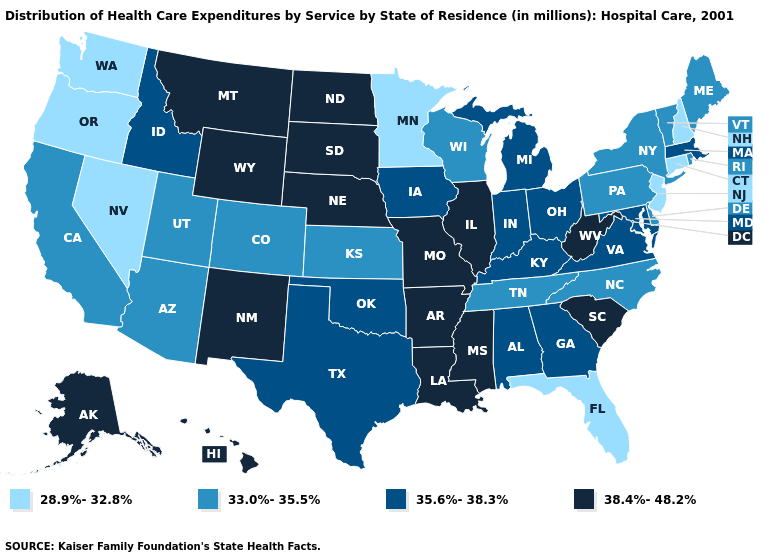What is the value of Alabama?
Quick response, please. 35.6%-38.3%. Name the states that have a value in the range 33.0%-35.5%?
Be succinct. Arizona, California, Colorado, Delaware, Kansas, Maine, New York, North Carolina, Pennsylvania, Rhode Island, Tennessee, Utah, Vermont, Wisconsin. What is the value of Vermont?
Answer briefly. 33.0%-35.5%. Name the states that have a value in the range 35.6%-38.3%?
Give a very brief answer. Alabama, Georgia, Idaho, Indiana, Iowa, Kentucky, Maryland, Massachusetts, Michigan, Ohio, Oklahoma, Texas, Virginia. Name the states that have a value in the range 35.6%-38.3%?
Short answer required. Alabama, Georgia, Idaho, Indiana, Iowa, Kentucky, Maryland, Massachusetts, Michigan, Ohio, Oklahoma, Texas, Virginia. Is the legend a continuous bar?
Give a very brief answer. No. What is the value of Maryland?
Concise answer only. 35.6%-38.3%. Among the states that border Oklahoma , which have the highest value?
Be succinct. Arkansas, Missouri, New Mexico. What is the highest value in the USA?
Write a very short answer. 38.4%-48.2%. Does Florida have a lower value than Alaska?
Answer briefly. Yes. Name the states that have a value in the range 28.9%-32.8%?
Short answer required. Connecticut, Florida, Minnesota, Nevada, New Hampshire, New Jersey, Oregon, Washington. How many symbols are there in the legend?
Give a very brief answer. 4. Name the states that have a value in the range 33.0%-35.5%?
Quick response, please. Arizona, California, Colorado, Delaware, Kansas, Maine, New York, North Carolina, Pennsylvania, Rhode Island, Tennessee, Utah, Vermont, Wisconsin. Does the first symbol in the legend represent the smallest category?
Short answer required. Yes. 